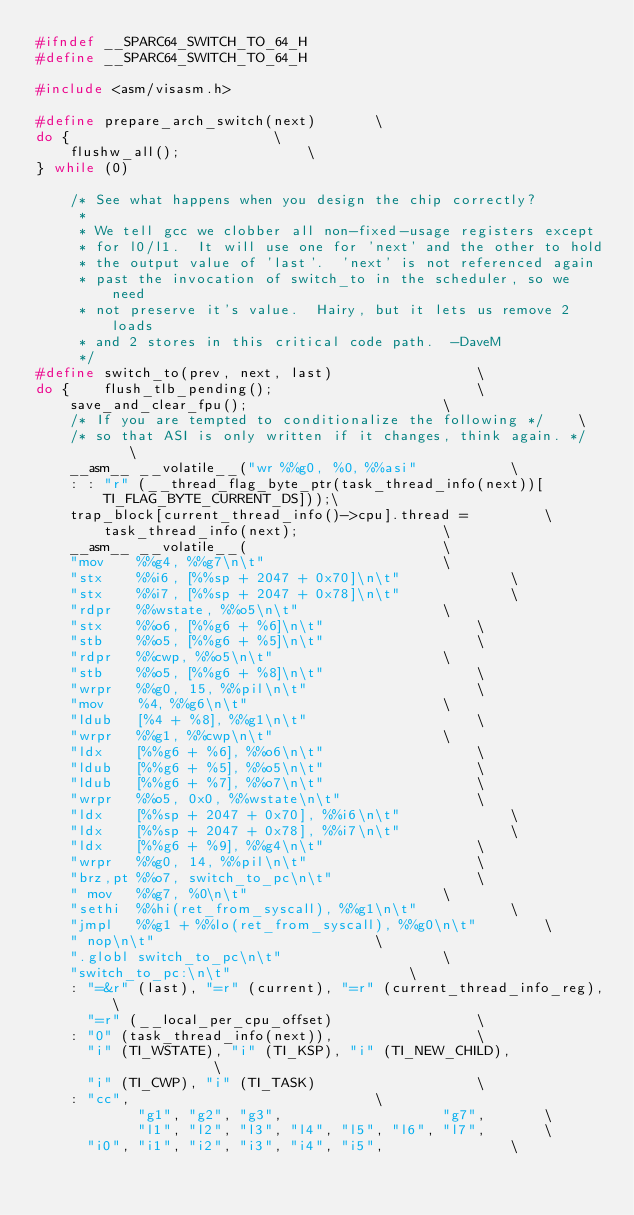Convert code to text. <code><loc_0><loc_0><loc_500><loc_500><_C_>#ifndef __SPARC64_SWITCH_TO_64_H
#define __SPARC64_SWITCH_TO_64_H

#include <asm/visasm.h>

#define prepare_arch_switch(next)		\
do {						\
	flushw_all();				\
} while (0)

	/* See what happens when you design the chip correctly?
	 *
	 * We tell gcc we clobber all non-fixed-usage registers except
	 * for l0/l1.  It will use one for 'next' and the other to hold
	 * the output value of 'last'.  'next' is not referenced again
	 * past the invocation of switch_to in the scheduler, so we need
	 * not preserve it's value.  Hairy, but it lets us remove 2 loads
	 * and 2 stores in this critical code path.  -DaveM
	 */
#define switch_to(prev, next, last)					\
do {	flush_tlb_pending();						\
	save_and_clear_fpu();						\
	/* If you are tempted to conditionalize the following */	\
	/* so that ASI is only written if it changes, think again. */	\
	__asm__ __volatile__("wr %%g0, %0, %%asi"			\
	: : "r" (__thread_flag_byte_ptr(task_thread_info(next))[TI_FLAG_BYTE_CURRENT_DS]));\
	trap_block[current_thread_info()->cpu].thread =			\
		task_thread_info(next);					\
	__asm__ __volatile__(						\
	"mov	%%g4, %%g7\n\t"						\
	"stx	%%i6, [%%sp + 2047 + 0x70]\n\t"				\
	"stx	%%i7, [%%sp + 2047 + 0x78]\n\t"				\
	"rdpr	%%wstate, %%o5\n\t"					\
	"stx	%%o6, [%%g6 + %6]\n\t"					\
	"stb	%%o5, [%%g6 + %5]\n\t"					\
	"rdpr	%%cwp, %%o5\n\t"					\
	"stb	%%o5, [%%g6 + %8]\n\t"					\
	"wrpr	%%g0, 15, %%pil\n\t"					\
	"mov	%4, %%g6\n\t"						\
	"ldub	[%4 + %8], %%g1\n\t"					\
	"wrpr	%%g1, %%cwp\n\t"					\
	"ldx	[%%g6 + %6], %%o6\n\t"					\
	"ldub	[%%g6 + %5], %%o5\n\t"					\
	"ldub	[%%g6 + %7], %%o7\n\t"					\
	"wrpr	%%o5, 0x0, %%wstate\n\t"				\
	"ldx	[%%sp + 2047 + 0x70], %%i6\n\t"				\
	"ldx	[%%sp + 2047 + 0x78], %%i7\n\t"				\
	"ldx	[%%g6 + %9], %%g4\n\t"					\
	"wrpr	%%g0, 14, %%pil\n\t"					\
	"brz,pt %%o7, switch_to_pc\n\t"					\
	" mov	%%g7, %0\n\t"						\
	"sethi	%%hi(ret_from_syscall), %%g1\n\t"			\
	"jmpl	%%g1 + %%lo(ret_from_syscall), %%g0\n\t"		\
	" nop\n\t"							\
	".globl switch_to_pc\n\t"					\
	"switch_to_pc:\n\t"						\
	: "=&r" (last), "=r" (current), "=r" (current_thread_info_reg),	\
	  "=r" (__local_per_cpu_offset)					\
	: "0" (task_thread_info(next)),					\
	  "i" (TI_WSTATE), "i" (TI_KSP), "i" (TI_NEW_CHILD),            \
	  "i" (TI_CWP), "i" (TI_TASK)					\
	: "cc",								\
	        "g1", "g2", "g3",                   "g7",		\
	        "l1", "l2", "l3", "l4", "l5", "l6", "l7",		\
	  "i0", "i1", "i2", "i3", "i4", "i5",				\</code> 